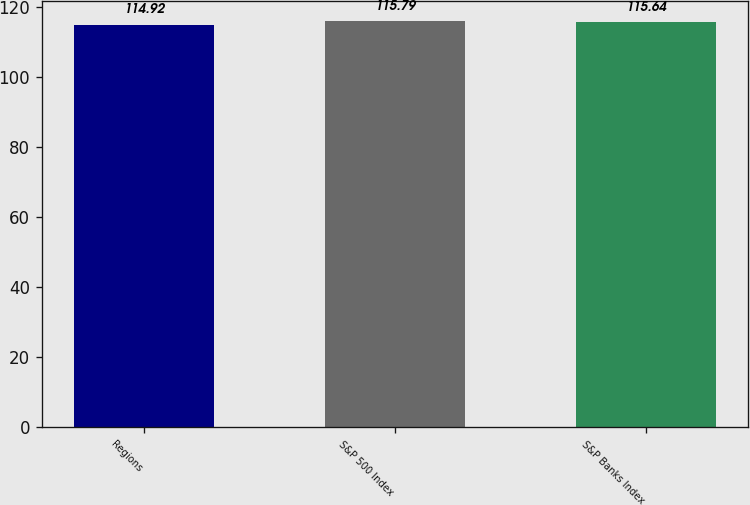<chart> <loc_0><loc_0><loc_500><loc_500><bar_chart><fcel>Regions<fcel>S&P 500 Index<fcel>S&P Banks Index<nl><fcel>114.92<fcel>115.79<fcel>115.64<nl></chart> 